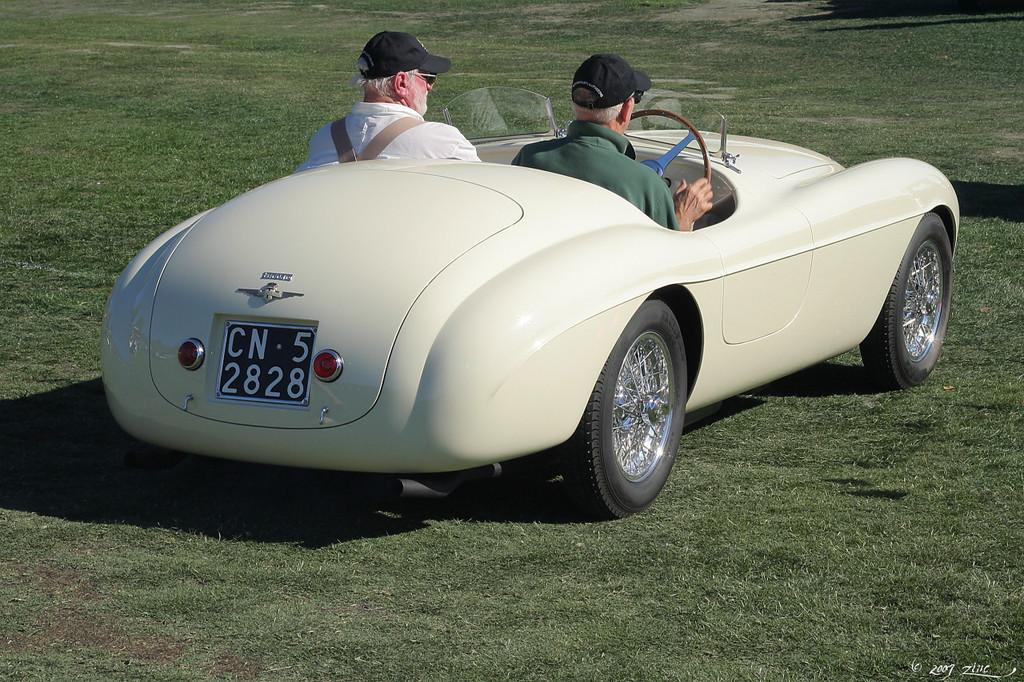How many people are in the image? There are two people in the image. What are the two people doing in the image? The two people are seated in a car. What type of haircut does the drawer have in the image? There is no drawer or haircut present in the image; it features two people seated in a car. What is the cause of the war depicted in the image? There is no war depicted in the image; it features two people seated in a car. 